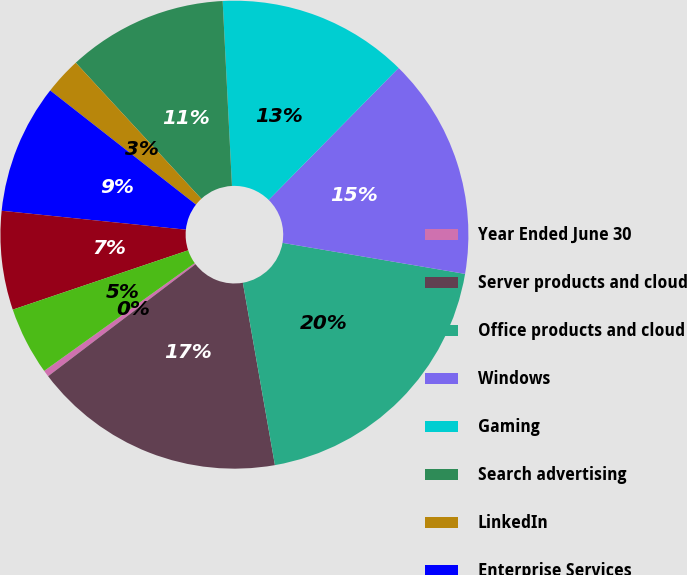Convert chart. <chart><loc_0><loc_0><loc_500><loc_500><pie_chart><fcel>Year Ended June 30<fcel>Server products and cloud<fcel>Office products and cloud<fcel>Windows<fcel>Gaming<fcel>Search advertising<fcel>LinkedIn<fcel>Enterprise Services<fcel>Devices<fcel>Other<nl><fcel>0.45%<fcel>17.43%<fcel>19.55%<fcel>15.3%<fcel>13.18%<fcel>11.06%<fcel>2.57%<fcel>8.94%<fcel>6.82%<fcel>4.7%<nl></chart> 